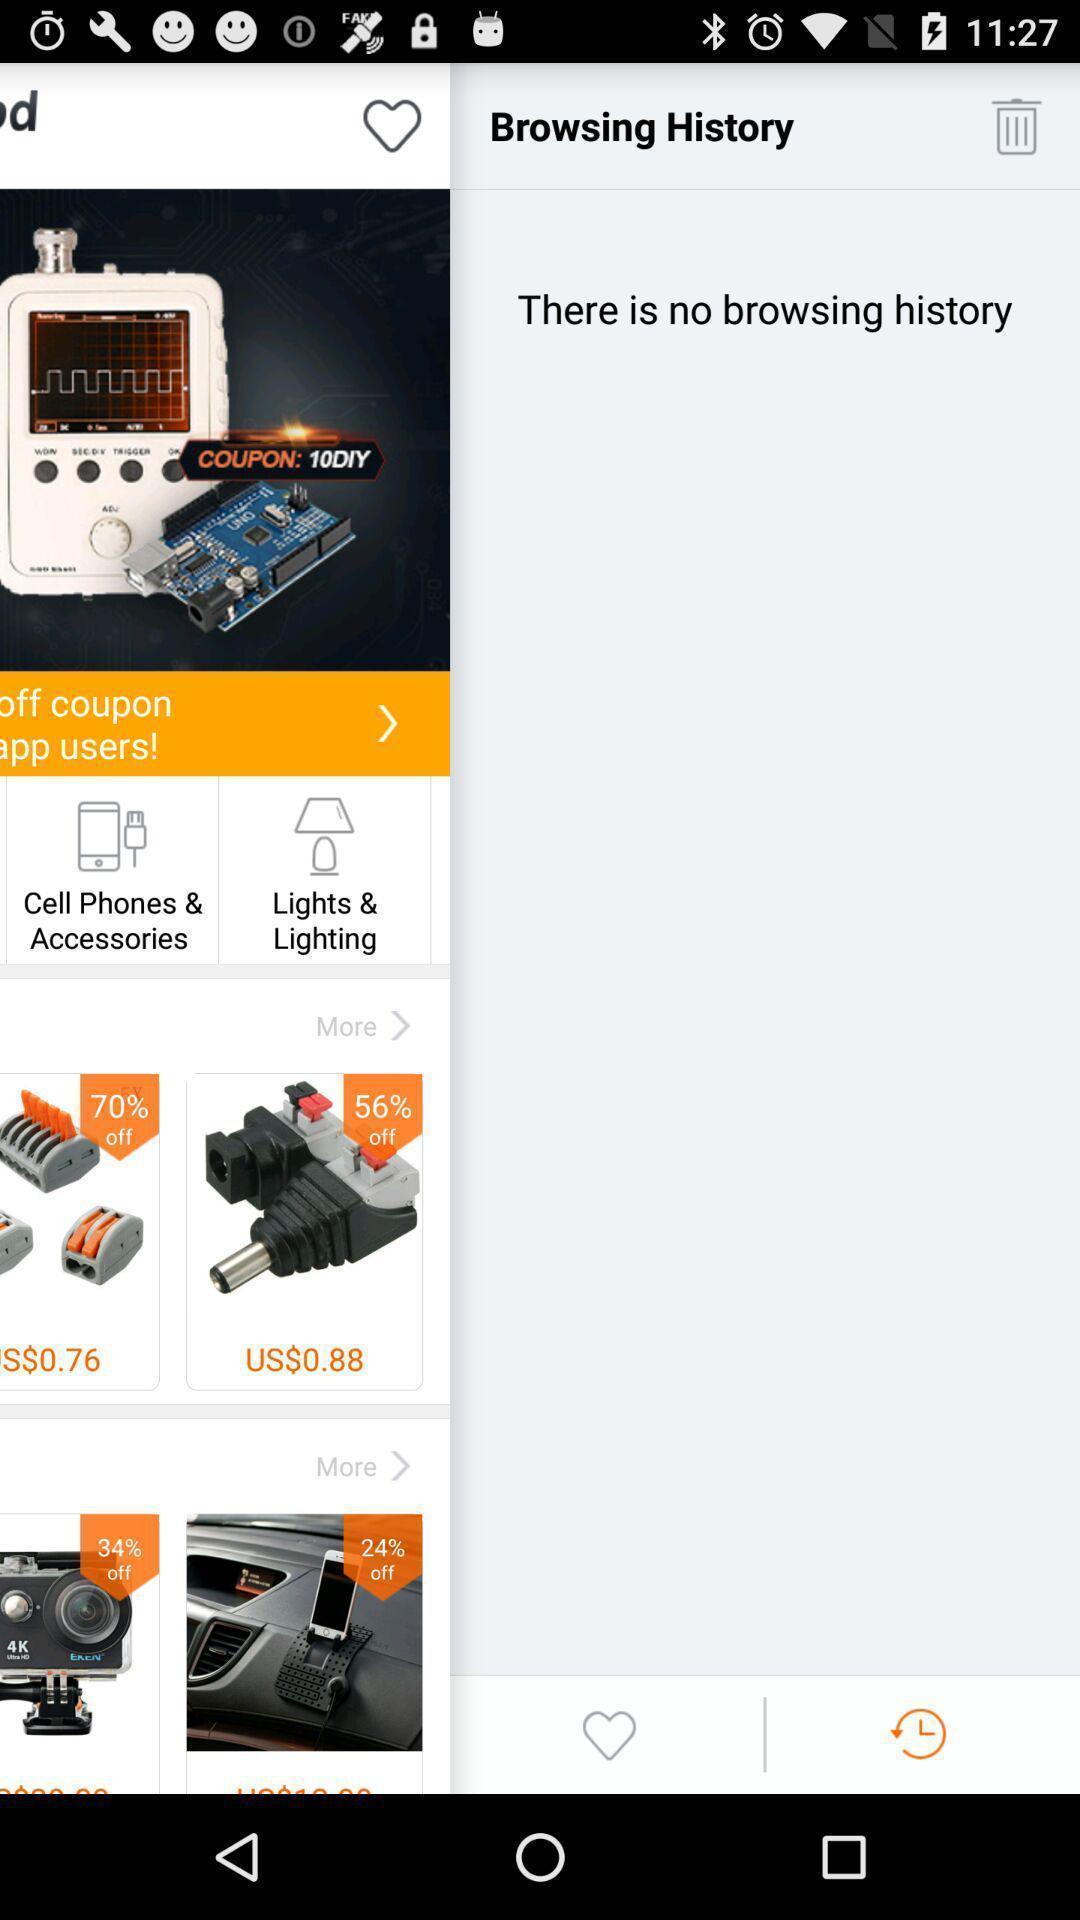Summarize the main components in this picture. Page showing status on your browsing history. 